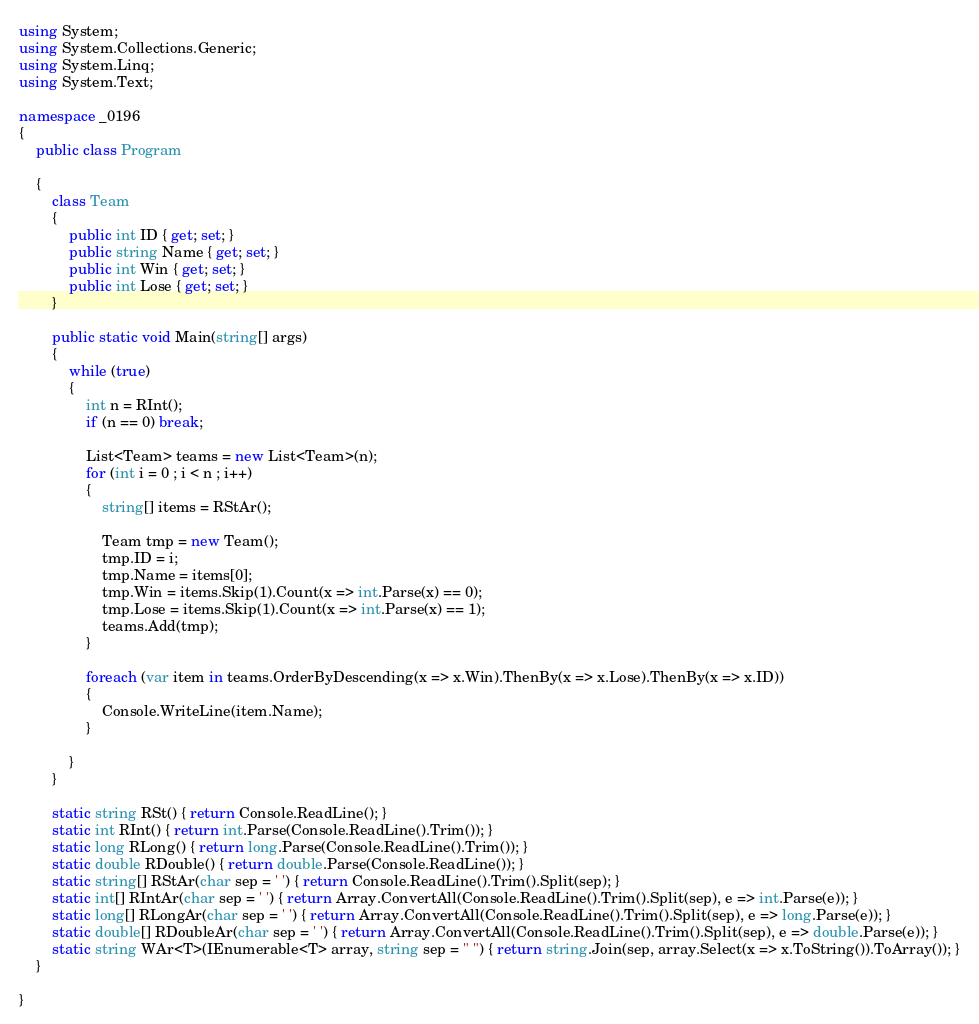Convert code to text. <code><loc_0><loc_0><loc_500><loc_500><_C#_>using System;
using System.Collections.Generic;
using System.Linq;
using System.Text;

namespace _0196
{
    public class Program

    {
        class Team
        {
            public int ID { get; set; }
            public string Name { get; set; }
            public int Win { get; set; }
            public int Lose { get; set; }
        }

        public static void Main(string[] args)
        {
            while (true)
            {
                int n = RInt();
                if (n == 0) break;

                List<Team> teams = new List<Team>(n);
                for (int i = 0 ; i < n ; i++)
                {
                    string[] items = RStAr();

                    Team tmp = new Team();
                    tmp.ID = i;
                    tmp.Name = items[0];
                    tmp.Win = items.Skip(1).Count(x => int.Parse(x) == 0);
                    tmp.Lose = items.Skip(1).Count(x => int.Parse(x) == 1);
                    teams.Add(tmp);
                }

                foreach (var item in teams.OrderByDescending(x => x.Win).ThenBy(x => x.Lose).ThenBy(x => x.ID))
                {
                    Console.WriteLine(item.Name);
                }

            }
        }

        static string RSt() { return Console.ReadLine(); }
        static int RInt() { return int.Parse(Console.ReadLine().Trim()); }
        static long RLong() { return long.Parse(Console.ReadLine().Trim()); }
        static double RDouble() { return double.Parse(Console.ReadLine()); }
        static string[] RStAr(char sep = ' ') { return Console.ReadLine().Trim().Split(sep); }
        static int[] RIntAr(char sep = ' ') { return Array.ConvertAll(Console.ReadLine().Trim().Split(sep), e => int.Parse(e)); }
        static long[] RLongAr(char sep = ' ') { return Array.ConvertAll(Console.ReadLine().Trim().Split(sep), e => long.Parse(e)); }
        static double[] RDoubleAr(char sep = ' ') { return Array.ConvertAll(Console.ReadLine().Trim().Split(sep), e => double.Parse(e)); }
        static string WAr<T>(IEnumerable<T> array, string sep = " ") { return string.Join(sep, array.Select(x => x.ToString()).ToArray()); }
    }

}

</code> 